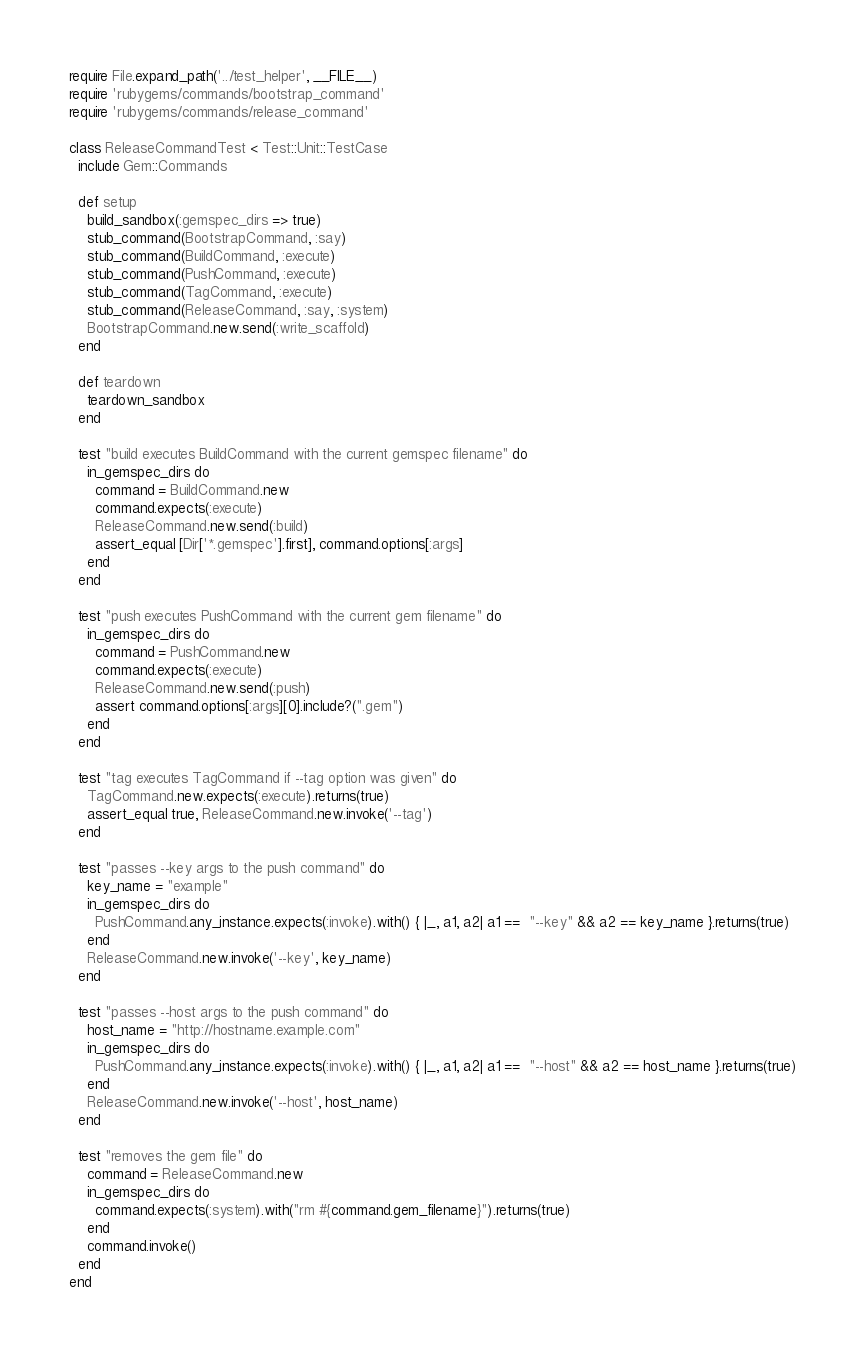<code> <loc_0><loc_0><loc_500><loc_500><_Ruby_>require File.expand_path('../test_helper', __FILE__)
require 'rubygems/commands/bootstrap_command'
require 'rubygems/commands/release_command'

class ReleaseCommandTest < Test::Unit::TestCase
  include Gem::Commands

  def setup
    build_sandbox(:gemspec_dirs => true)
    stub_command(BootstrapCommand, :say)
    stub_command(BuildCommand, :execute)
    stub_command(PushCommand, :execute)
    stub_command(TagCommand, :execute)
    stub_command(ReleaseCommand, :say, :system)
    BootstrapCommand.new.send(:write_scaffold)
  end

  def teardown
    teardown_sandbox
  end

  test "build executes BuildCommand with the current gemspec filename" do
    in_gemspec_dirs do
      command = BuildCommand.new
      command.expects(:execute)
      ReleaseCommand.new.send(:build)
      assert_equal [Dir['*.gemspec'].first], command.options[:args]
    end
  end

  test "push executes PushCommand with the current gem filename" do
    in_gemspec_dirs do
      command = PushCommand.new
      command.expects(:execute)
      ReleaseCommand.new.send(:push)
      assert command.options[:args][0].include?(".gem")
    end
  end

  test "tag executes TagCommand if --tag option was given" do
    TagCommand.new.expects(:execute).returns(true)
    assert_equal true, ReleaseCommand.new.invoke('--tag')
  end

  test "passes --key args to the push command" do
    key_name = "example"
    in_gemspec_dirs do
      PushCommand.any_instance.expects(:invoke).with() { |_, a1, a2| a1 ==  "--key" && a2 == key_name }.returns(true)
    end
    ReleaseCommand.new.invoke('--key', key_name)
  end

  test "passes --host args to the push command" do
    host_name = "http://hostname.example.com"
    in_gemspec_dirs do
      PushCommand.any_instance.expects(:invoke).with() { |_, a1, a2| a1 ==  "--host" && a2 == host_name }.returns(true)
    end
    ReleaseCommand.new.invoke('--host', host_name)
  end

  test "removes the gem file" do
    command = ReleaseCommand.new
    in_gemspec_dirs do
      command.expects(:system).with("rm #{command.gem_filename}").returns(true)
    end
    command.invoke()
  end
end
</code> 